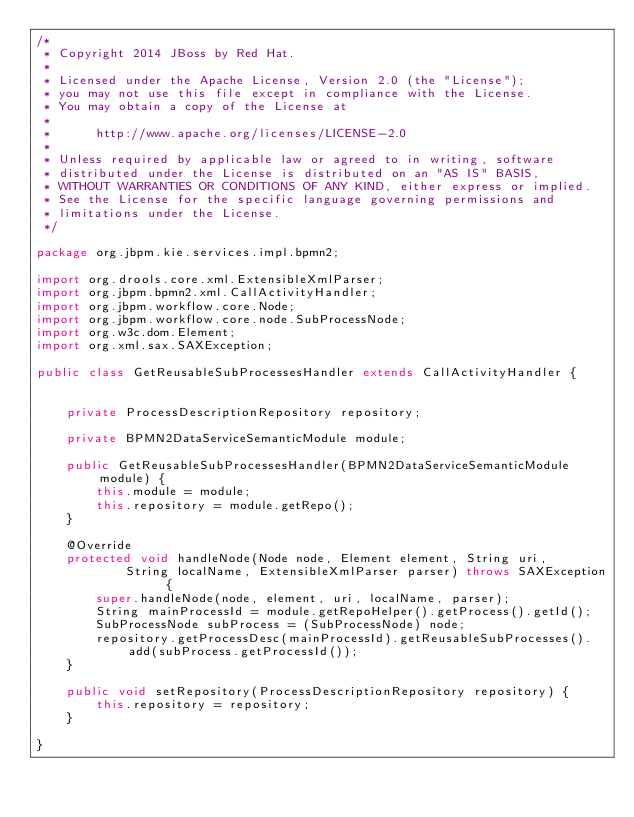Convert code to text. <code><loc_0><loc_0><loc_500><loc_500><_Java_>/*
 * Copyright 2014 JBoss by Red Hat.
 *
 * Licensed under the Apache License, Version 2.0 (the "License");
 * you may not use this file except in compliance with the License.
 * You may obtain a copy of the License at
 *
 *      http://www.apache.org/licenses/LICENSE-2.0
 *
 * Unless required by applicable law or agreed to in writing, software
 * distributed under the License is distributed on an "AS IS" BASIS,
 * WITHOUT WARRANTIES OR CONDITIONS OF ANY KIND, either express or implied.
 * See the License for the specific language governing permissions and
 * limitations under the License.
 */

package org.jbpm.kie.services.impl.bpmn2;

import org.drools.core.xml.ExtensibleXmlParser;
import org.jbpm.bpmn2.xml.CallActivityHandler;
import org.jbpm.workflow.core.Node;
import org.jbpm.workflow.core.node.SubProcessNode;
import org.w3c.dom.Element;
import org.xml.sax.SAXException;

public class GetReusableSubProcessesHandler extends CallActivityHandler {

    
    private ProcessDescriptionRepository repository;
    
    private BPMN2DataServiceSemanticModule module;
    
    public GetReusableSubProcessesHandler(BPMN2DataServiceSemanticModule module) {
		this.module = module;
    	this.repository = module.getRepo();
	}
    
    @Override
    protected void handleNode(Node node, Element element, String uri,
            String localName, ExtensibleXmlParser parser) throws SAXException {
        super.handleNode(node, element, uri, localName, parser);
        String mainProcessId = module.getRepoHelper().getProcess().getId();
        SubProcessNode subProcess = (SubProcessNode) node;
        repository.getProcessDesc(mainProcessId).getReusableSubProcesses().add(subProcess.getProcessId());
    }

    public void setRepository(ProcessDescriptionRepository repository) {
        this.repository = repository;
    }
    
}
</code> 